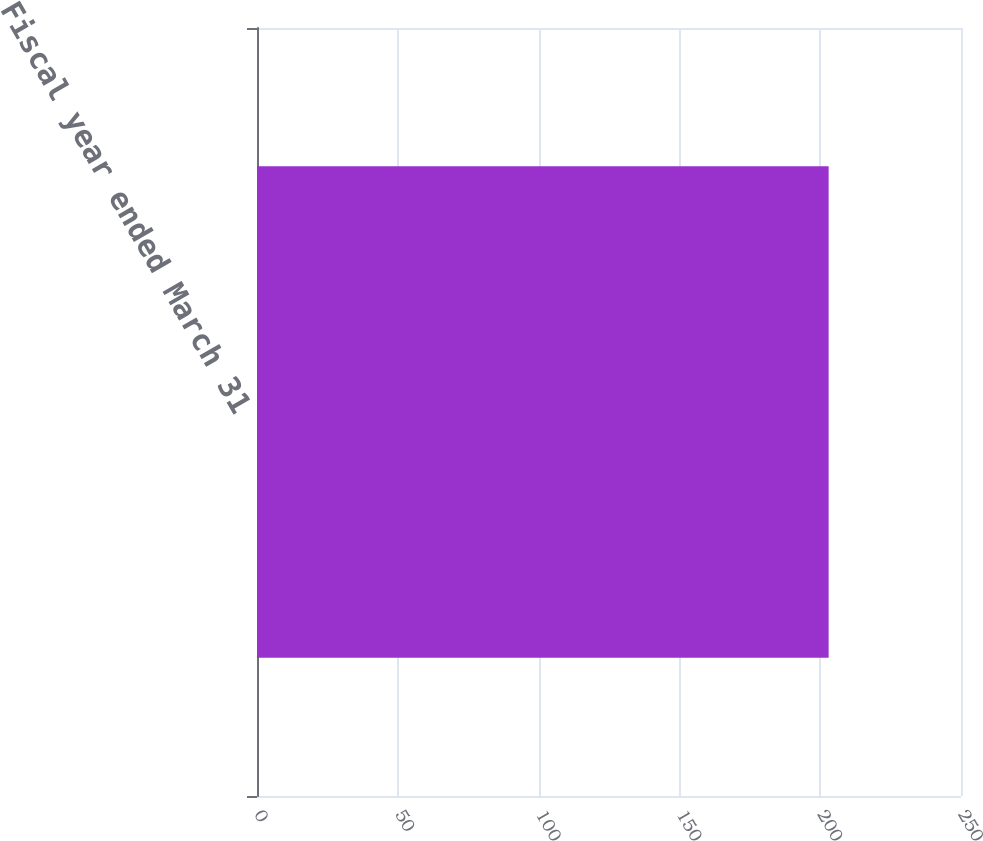<chart> <loc_0><loc_0><loc_500><loc_500><bar_chart><fcel>Fiscal year ended March 31<nl><fcel>203<nl></chart> 